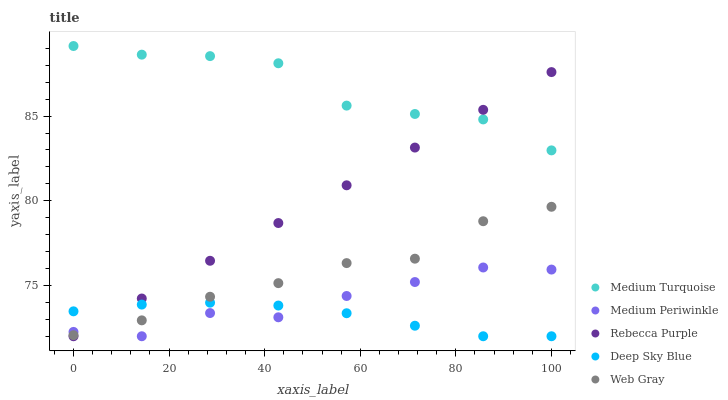Does Deep Sky Blue have the minimum area under the curve?
Answer yes or no. Yes. Does Medium Turquoise have the maximum area under the curve?
Answer yes or no. Yes. Does Web Gray have the minimum area under the curve?
Answer yes or no. No. Does Web Gray have the maximum area under the curve?
Answer yes or no. No. Is Rebecca Purple the smoothest?
Answer yes or no. Yes. Is Medium Turquoise the roughest?
Answer yes or no. Yes. Is Web Gray the smoothest?
Answer yes or no. No. Is Web Gray the roughest?
Answer yes or no. No. Does Deep Sky Blue have the lowest value?
Answer yes or no. Yes. Does Web Gray have the lowest value?
Answer yes or no. No. Does Medium Turquoise have the highest value?
Answer yes or no. Yes. Does Web Gray have the highest value?
Answer yes or no. No. Is Web Gray less than Medium Turquoise?
Answer yes or no. Yes. Is Medium Turquoise greater than Web Gray?
Answer yes or no. Yes. Does Deep Sky Blue intersect Web Gray?
Answer yes or no. Yes. Is Deep Sky Blue less than Web Gray?
Answer yes or no. No. Is Deep Sky Blue greater than Web Gray?
Answer yes or no. No. Does Web Gray intersect Medium Turquoise?
Answer yes or no. No. 